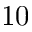<formula> <loc_0><loc_0><loc_500><loc_500>1 0</formula> 